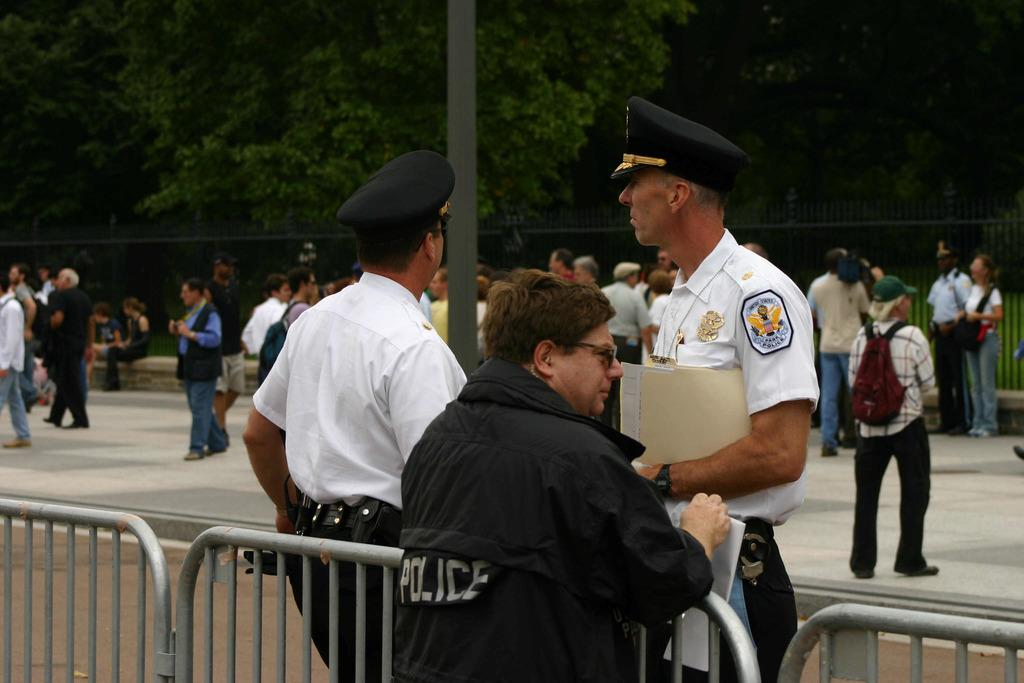What type of structure can be seen in the image? There are handrails in the image, which suggests a staircase or similar structure. What is the main subject in the foreground of the image? A cop is standing in the foreground of the image. How many people are visible behind the cop? There are many other people behind the cop in the image. What can be seen in the background of the image? There are trees in the background of the image. Can you see a flower in the image? There is no flower visible in the image. Is the cop sleeping in the image? The cop is standing in the image, not sleeping. 